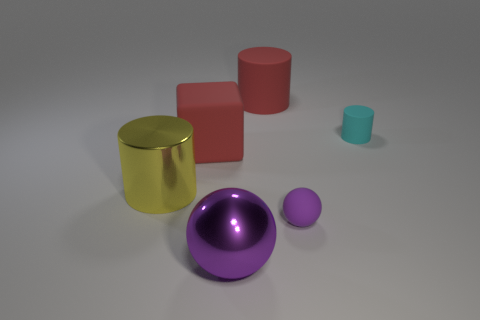Add 2 gray rubber things. How many objects exist? 8 Subtract all tiny cyan cylinders. How many cylinders are left? 2 Subtract all cyan cylinders. How many cylinders are left? 2 Subtract all cubes. How many objects are left? 5 Add 5 purple rubber things. How many purple rubber things are left? 6 Add 6 big yellow balls. How many big yellow balls exist? 6 Subtract 1 purple balls. How many objects are left? 5 Subtract all green cylinders. Subtract all purple spheres. How many cylinders are left? 3 Subtract all big blue objects. Subtract all red matte blocks. How many objects are left? 5 